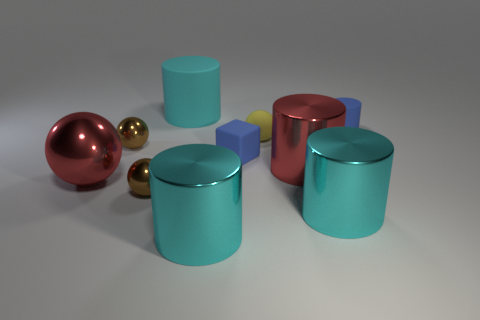Can you tell me the materials these objects might be made from just by looking at them? While I cannot determine with certainty the materials of the objects without physical examination, based on their appearances, the spheres and cylinders exhibit metallic reflections indicative of metal or metal-like materials. The smaller cubes have a matte finish, suggesting they could be made from a non-metallic substance such as plastic or rubber. 